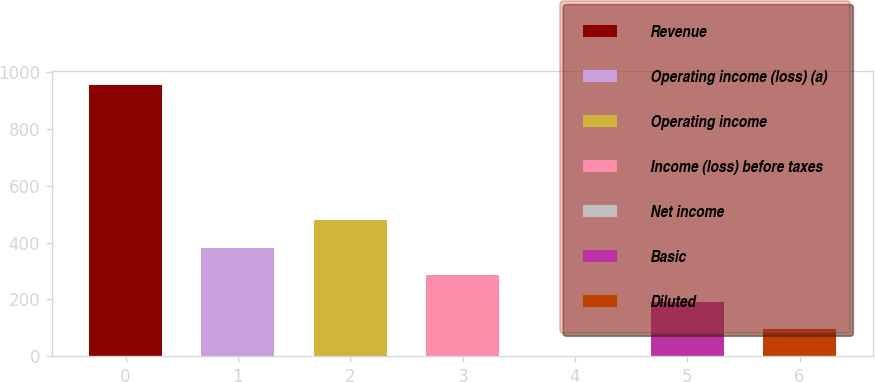<chart> <loc_0><loc_0><loc_500><loc_500><bar_chart><fcel>Revenue<fcel>Operating income (loss) (a)<fcel>Operating income<fcel>Income (loss) before taxes<fcel>Net income<fcel>Basic<fcel>Diluted<nl><fcel>955.6<fcel>382.54<fcel>478.05<fcel>287.03<fcel>0.5<fcel>191.52<fcel>96.01<nl></chart> 